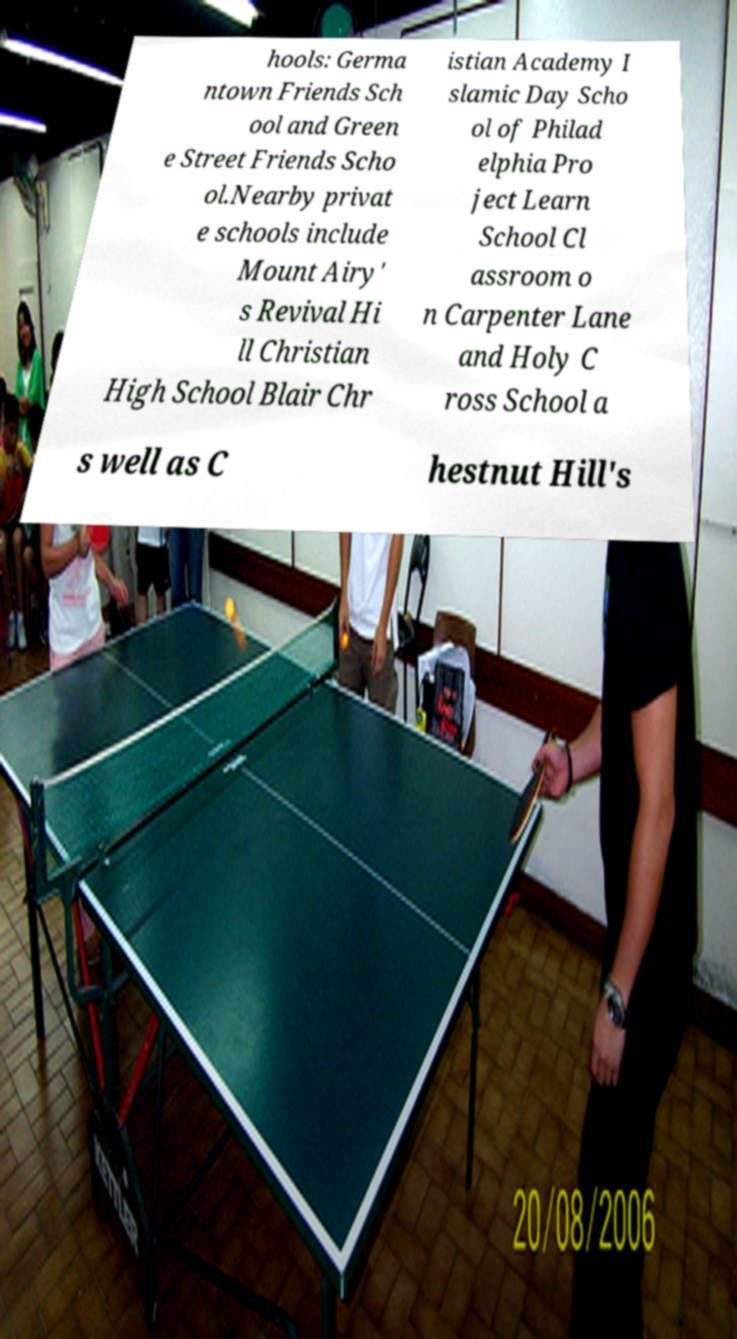Could you extract and type out the text from this image? hools: Germa ntown Friends Sch ool and Green e Street Friends Scho ol.Nearby privat e schools include Mount Airy' s Revival Hi ll Christian High School Blair Chr istian Academy I slamic Day Scho ol of Philad elphia Pro ject Learn School Cl assroom o n Carpenter Lane and Holy C ross School a s well as C hestnut Hill's 